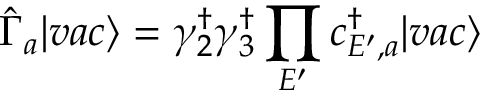Convert formula to latex. <formula><loc_0><loc_0><loc_500><loc_500>\hat { \Gamma } _ { a } | v a c \rangle = \gamma _ { 2 } ^ { \dagger } \gamma _ { 3 } ^ { \dagger } \prod _ { E ^ { \prime } } c _ { E ^ { \prime } , a } ^ { \dagger } | v a c \rangle</formula> 